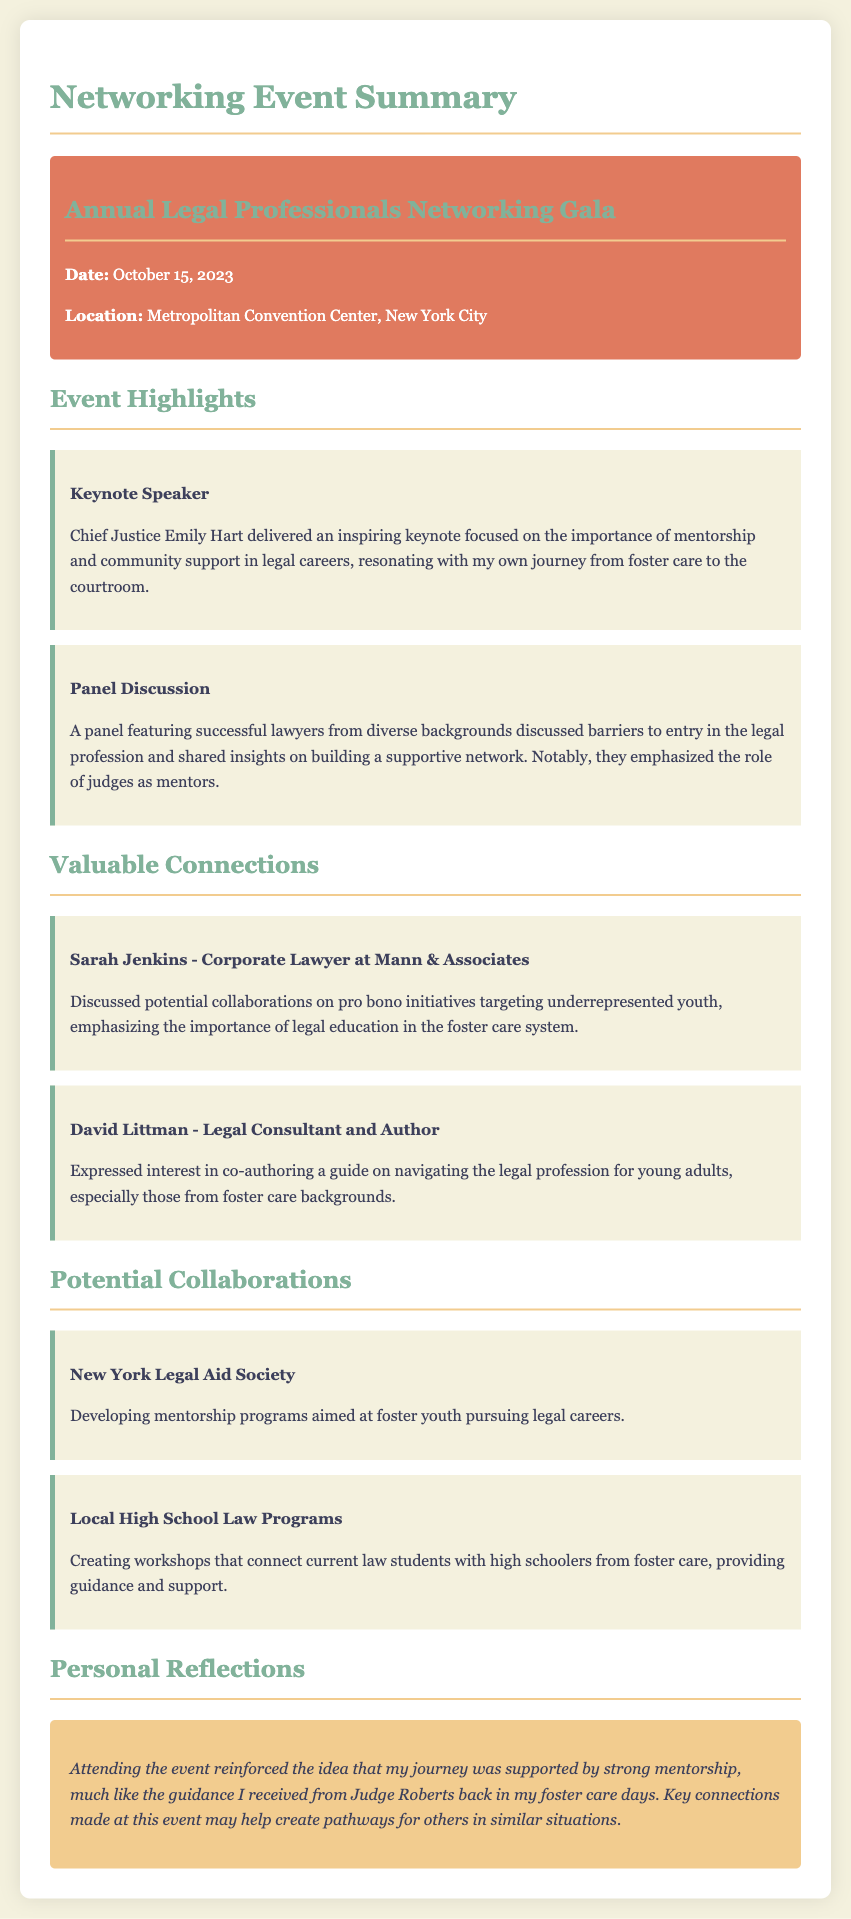what was the date of the event? The date of the event is explicitly stated in the document as October 15, 2023.
Answer: October 15, 2023 who was the keynote speaker? The keynote speaker is listed in the document as Chief Justice Emily Hart.
Answer: Chief Justice Emily Hart what organization is mentioned for potential collaboration on mentorship programs? The document specifies the New York Legal Aid Society as the organization for developing mentorship programs.
Answer: New York Legal Aid Society who discussed co-authoring a guide on navigating the legal profession? The document mentions David Littman as the person who expressed interest in co-authoring a guide.
Answer: David Littman what was the location of the networking event? The networking event's location is stated as the Metropolitan Convention Center, New York City.
Answer: Metropolitan Convention Center, New York City what common theme was emphasized by the panel discussion? The panel discussed barriers to entry in the legal profession, with a common theme of support from judges as mentors.
Answer: support from judges as mentors how did the event influence the personal reflections mentioned? The reflections indicate that the event reinforced the belief in the importance of mentorship, similar to the guidance received from Judge Roberts.
Answer: guidance received from Judge Roberts what is a potential collaboration with local high schools about? The document specifies creating workshops that connect current law students with high schoolers from foster care.
Answer: creating workshops 